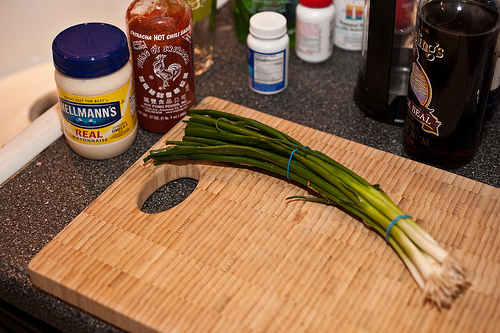<image>
Is the cutting board on the table? Yes. Looking at the image, I can see the cutting board is positioned on top of the table, with the table providing support. 